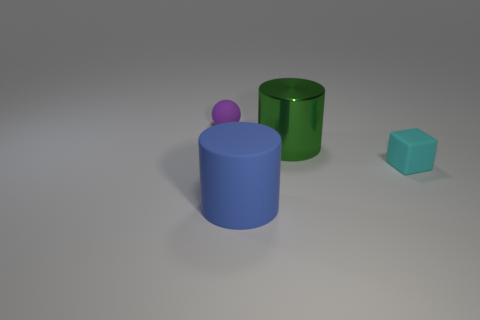Do the matte cube and the shiny cylinder have the same size?
Your answer should be compact. No. There is a thing that is on the right side of the large rubber object and in front of the big green cylinder; how big is it?
Offer a very short reply. Small. Are there more small cyan things to the right of the cyan rubber thing than matte cylinders right of the green metal thing?
Ensure brevity in your answer.  No. The shiny thing that is the same shape as the blue rubber object is what color?
Keep it short and to the point. Green. Does the rubber thing right of the large rubber thing have the same color as the metal cylinder?
Ensure brevity in your answer.  No. How many red cylinders are there?
Ensure brevity in your answer.  0. Are the big thing behind the large blue rubber cylinder and the ball made of the same material?
Provide a short and direct response. No. Are there any other things that are made of the same material as the small cube?
Give a very brief answer. Yes. There is a small matte thing that is behind the large thing that is behind the cyan matte object; what number of small things are on the right side of it?
Give a very brief answer. 1. What size is the cyan object?
Keep it short and to the point. Small. 